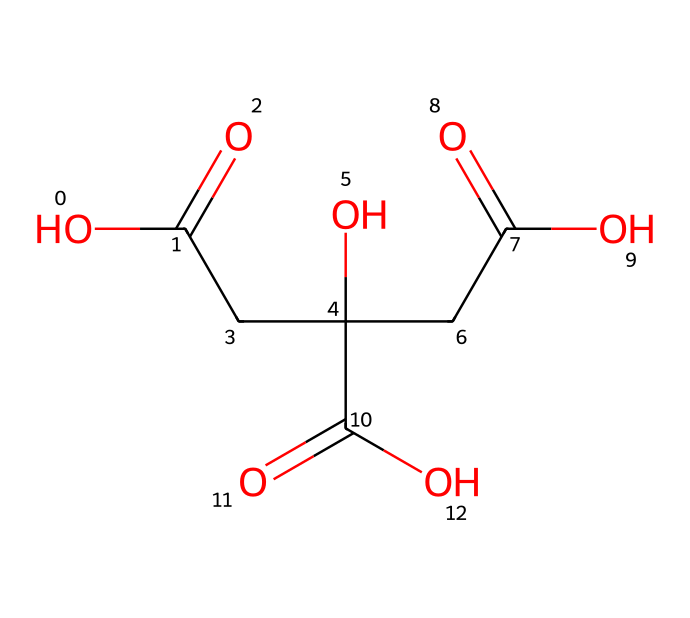What is the full name of the compound represented by the SMILES? The SMILES indicates a compound with three carboxylic acid groups (identified by the -C(=O)O) and a central carbon chain. This corresponds to citric acid.
Answer: citric acid How many carbon atoms are in the structure? From analyzing the SMILES, there are 6 carbon (C) atoms present as indicated by countable segments and the overall structure.
Answer: 6 What type of functional group is mainly present in citric acid? Citric acid is characterized by the presence of carboxylic acid functional groups which are denoted by -C(=O)O in the structure.
Answer: carboxylic acid How many hydroxyl groups are in citric acid? The presence of hydroxyl groups (-OH) can be identified and counted in the structure, leading to a total of one hydroxyl group indicated by the -O within the molecular structure.
Answer: 1 What kind of compound is citric acid classified as? Considering the structure and the presence of carbon, hydrogen, and multiple carboxylic acid groups, citric acid fits the classification of an aliphatic compound, more specifically a tricarboxylic acid.
Answer: tricarboxylic acid Which type of acid does citric acid belong to? In reviewing the functional groups and structure in the SMILES, citric acid is primarily categorized as an organic acid, specifically due to the presence of multiple carboxylic acid groups.
Answer: organic acid 